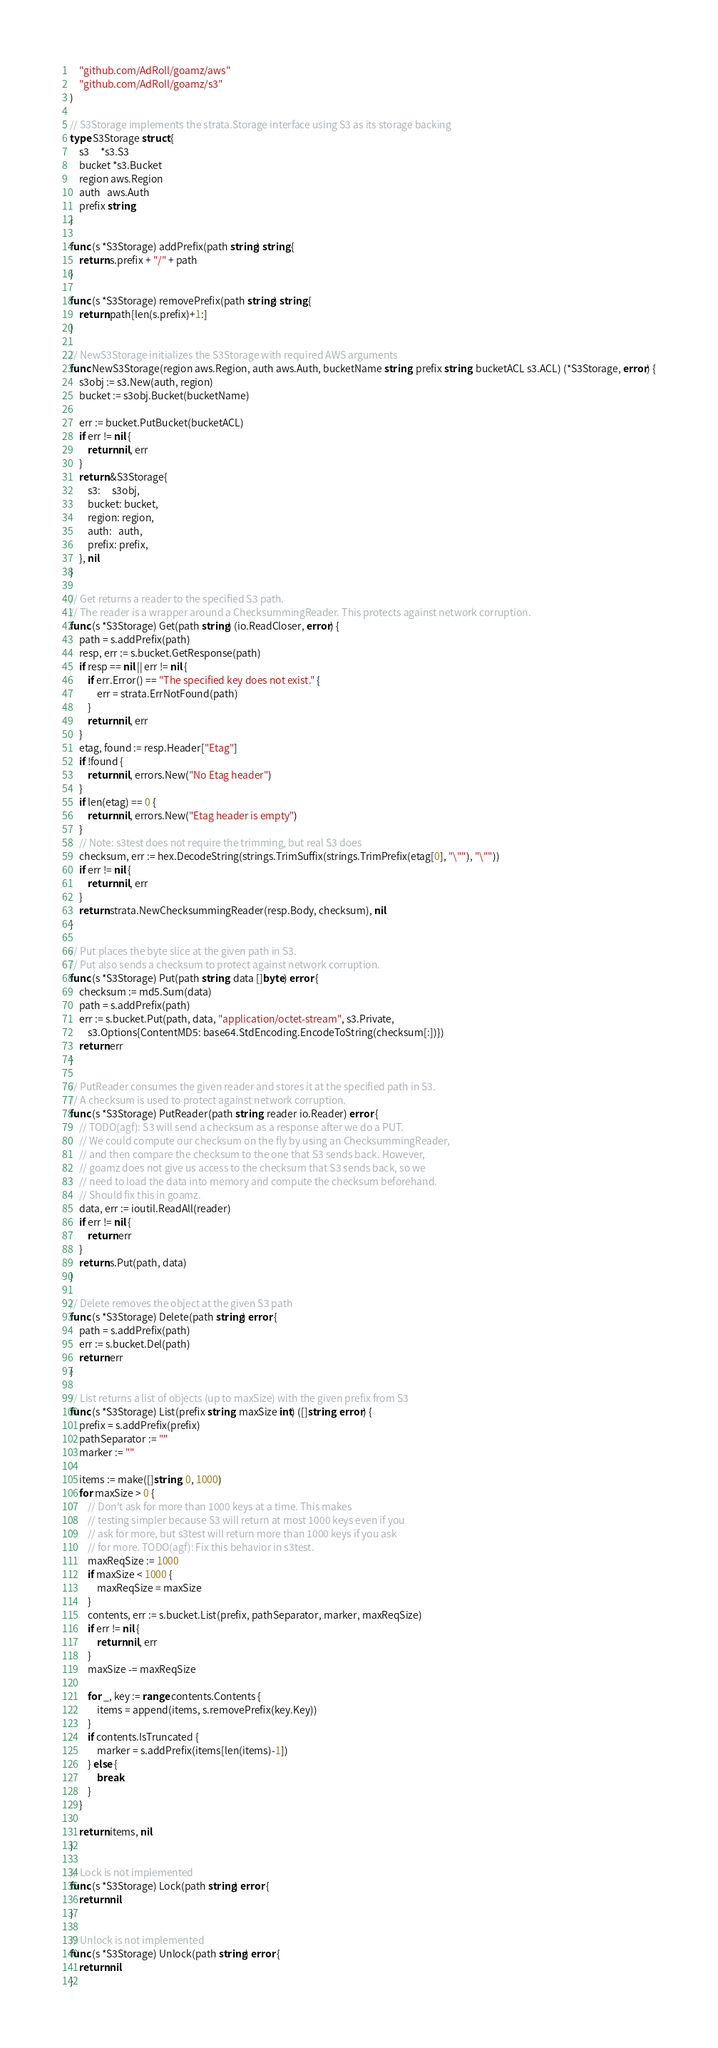Convert code to text. <code><loc_0><loc_0><loc_500><loc_500><_Go_>
	"github.com/AdRoll/goamz/aws"
	"github.com/AdRoll/goamz/s3"
)

// S3Storage implements the strata.Storage interface using S3 as its storage backing
type S3Storage struct {
	s3     *s3.S3
	bucket *s3.Bucket
	region aws.Region
	auth   aws.Auth
	prefix string
}

func (s *S3Storage) addPrefix(path string) string {
	return s.prefix + "/" + path
}

func (s *S3Storage) removePrefix(path string) string {
	return path[len(s.prefix)+1:]
}

// NewS3Storage initializes the S3Storage with required AWS arguments
func NewS3Storage(region aws.Region, auth aws.Auth, bucketName string, prefix string, bucketACL s3.ACL) (*S3Storage, error) {
	s3obj := s3.New(auth, region)
	bucket := s3obj.Bucket(bucketName)

	err := bucket.PutBucket(bucketACL)
	if err != nil {
		return nil, err
	}
	return &S3Storage{
		s3:     s3obj,
		bucket: bucket,
		region: region,
		auth:   auth,
		prefix: prefix,
	}, nil
}

// Get returns a reader to the specified S3 path.
// The reader is a wrapper around a ChecksummingReader. This protects against network corruption.
func (s *S3Storage) Get(path string) (io.ReadCloser, error) {
	path = s.addPrefix(path)
	resp, err := s.bucket.GetResponse(path)
	if resp == nil || err != nil {
		if err.Error() == "The specified key does not exist." {
			err = strata.ErrNotFound(path)
		}
		return nil, err
	}
	etag, found := resp.Header["Etag"]
	if !found {
		return nil, errors.New("No Etag header")
	}
	if len(etag) == 0 {
		return nil, errors.New("Etag header is empty")
	}
	// Note: s3test does not require the trimming, but real S3 does
	checksum, err := hex.DecodeString(strings.TrimSuffix(strings.TrimPrefix(etag[0], "\""), "\""))
	if err != nil {
		return nil, err
	}
	return strata.NewChecksummingReader(resp.Body, checksum), nil
}

// Put places the byte slice at the given path in S3.
// Put also sends a checksum to protect against network corruption.
func (s *S3Storage) Put(path string, data []byte) error {
	checksum := md5.Sum(data)
	path = s.addPrefix(path)
	err := s.bucket.Put(path, data, "application/octet-stream", s3.Private,
		s3.Options{ContentMD5: base64.StdEncoding.EncodeToString(checksum[:])})
	return err
}

// PutReader consumes the given reader and stores it at the specified path in S3.
// A checksum is used to protect against network corruption.
func (s *S3Storage) PutReader(path string, reader io.Reader) error {
	// TODO(agf): S3 will send a checksum as a response after we do a PUT.
	// We could compute our checksum on the fly by using an ChecksummingReader,
	// and then compare the checksum to the one that S3 sends back. However,
	// goamz does not give us access to the checksum that S3 sends back, so we
	// need to load the data into memory and compute the checksum beforehand.
	// Should fix this in goamz.
	data, err := ioutil.ReadAll(reader)
	if err != nil {
		return err
	}
	return s.Put(path, data)
}

// Delete removes the object at the given S3 path
func (s *S3Storage) Delete(path string) error {
	path = s.addPrefix(path)
	err := s.bucket.Del(path)
	return err
}

// List returns a list of objects (up to maxSize) with the given prefix from S3
func (s *S3Storage) List(prefix string, maxSize int) ([]string, error) {
	prefix = s.addPrefix(prefix)
	pathSeparator := ""
	marker := ""

	items := make([]string, 0, 1000)
	for maxSize > 0 {
		// Don't ask for more than 1000 keys at a time. This makes
		// testing simpler because S3 will return at most 1000 keys even if you
		// ask for more, but s3test will return more than 1000 keys if you ask
		// for more. TODO(agf): Fix this behavior in s3test.
		maxReqSize := 1000
		if maxSize < 1000 {
			maxReqSize = maxSize
		}
		contents, err := s.bucket.List(prefix, pathSeparator, marker, maxReqSize)
		if err != nil {
			return nil, err
		}
		maxSize -= maxReqSize

		for _, key := range contents.Contents {
			items = append(items, s.removePrefix(key.Key))
		}
		if contents.IsTruncated {
			marker = s.addPrefix(items[len(items)-1])
		} else {
			break
		}
	}

	return items, nil
}

// Lock is not implemented
func (s *S3Storage) Lock(path string) error {
	return nil
}

// Unlock is not implemented
func (s *S3Storage) Unlock(path string) error {
	return nil
}
</code> 